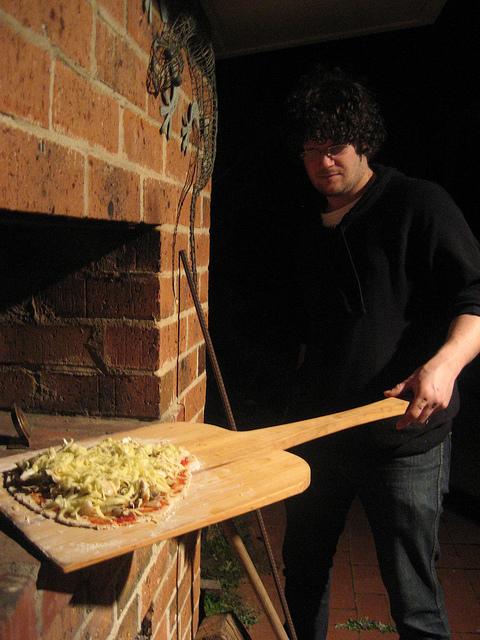What is the oven made out of?
Concise answer only. Brick. What color is the man's shirt?
Keep it brief. Black. What is this person putting into the oven?
Be succinct. Pizza. 